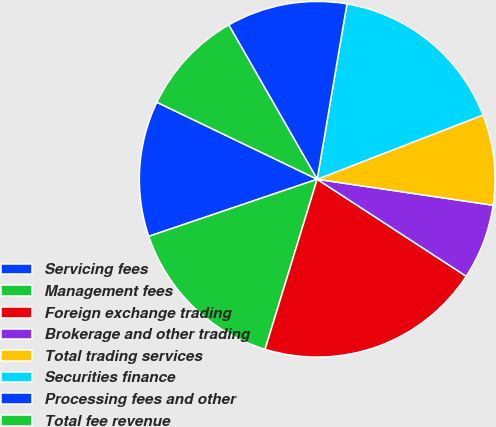Convert chart. <chart><loc_0><loc_0><loc_500><loc_500><pie_chart><fcel>Servicing fees<fcel>Management fees<fcel>Foreign exchange trading<fcel>Brokerage and other trading<fcel>Total trading services<fcel>Securities finance<fcel>Processing fees and other<fcel>Total fee revenue<nl><fcel>12.33%<fcel>15.07%<fcel>20.55%<fcel>6.85%<fcel>8.22%<fcel>16.44%<fcel>10.96%<fcel>9.59%<nl></chart> 